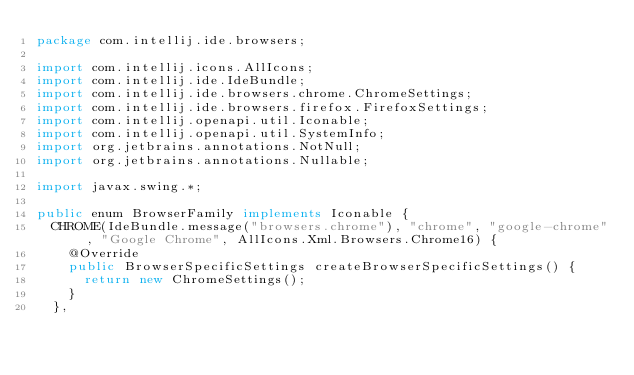Convert code to text. <code><loc_0><loc_0><loc_500><loc_500><_Java_>package com.intellij.ide.browsers;

import com.intellij.icons.AllIcons;
import com.intellij.ide.IdeBundle;
import com.intellij.ide.browsers.chrome.ChromeSettings;
import com.intellij.ide.browsers.firefox.FirefoxSettings;
import com.intellij.openapi.util.Iconable;
import com.intellij.openapi.util.SystemInfo;
import org.jetbrains.annotations.NotNull;
import org.jetbrains.annotations.Nullable;

import javax.swing.*;

public enum BrowserFamily implements Iconable {
  CHROME(IdeBundle.message("browsers.chrome"), "chrome", "google-chrome", "Google Chrome", AllIcons.Xml.Browsers.Chrome16) {
    @Override
    public BrowserSpecificSettings createBrowserSpecificSettings() {
      return new ChromeSettings();
    }
  },</code> 